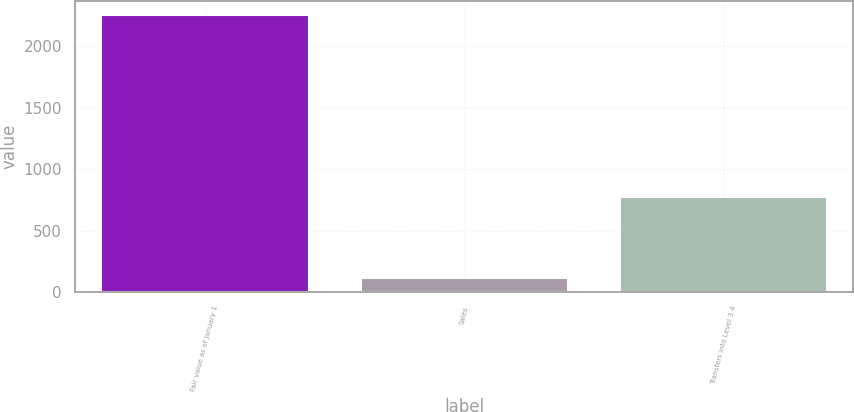<chart> <loc_0><loc_0><loc_500><loc_500><bar_chart><fcel>Fair value as of January 1<fcel>Sales<fcel>Transfers into Level 3 4<nl><fcel>2255<fcel>114<fcel>775<nl></chart> 